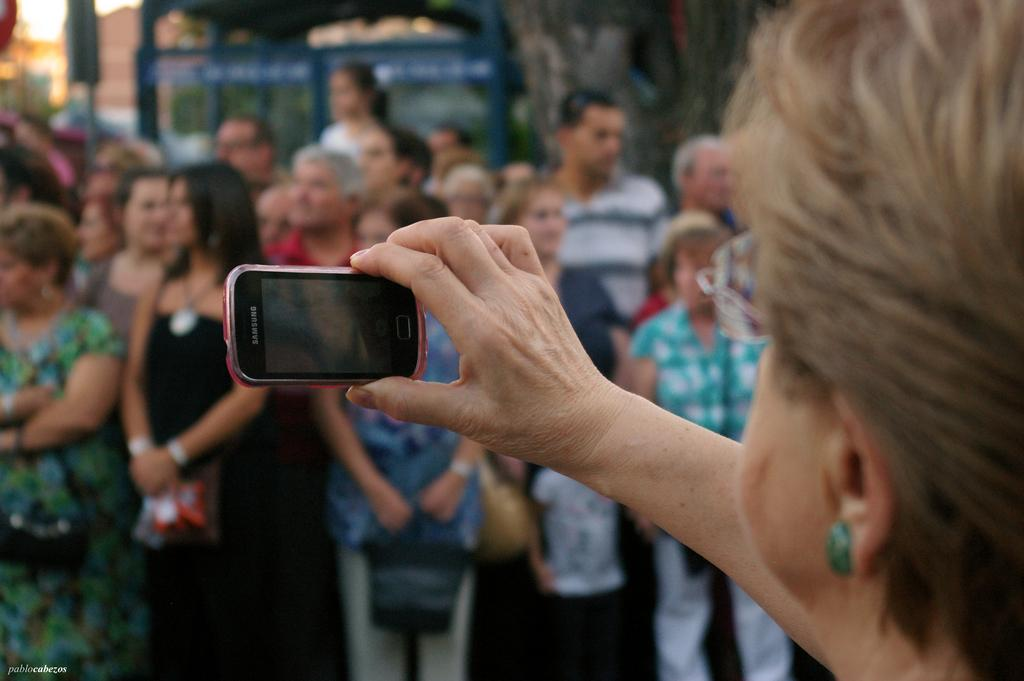Who is the main subject in the image? There is a woman in the image. What is the woman holding in the image? The woman is holding a mobile in the image. Can you describe the background of the image? There are people standing in the background of the image. What type of boundary is visible in the image? There is no boundary visible in the image. Is the woman using a quill to write in the image? There is no quill present in the image, and the woman is holding a mobile, not writing. 